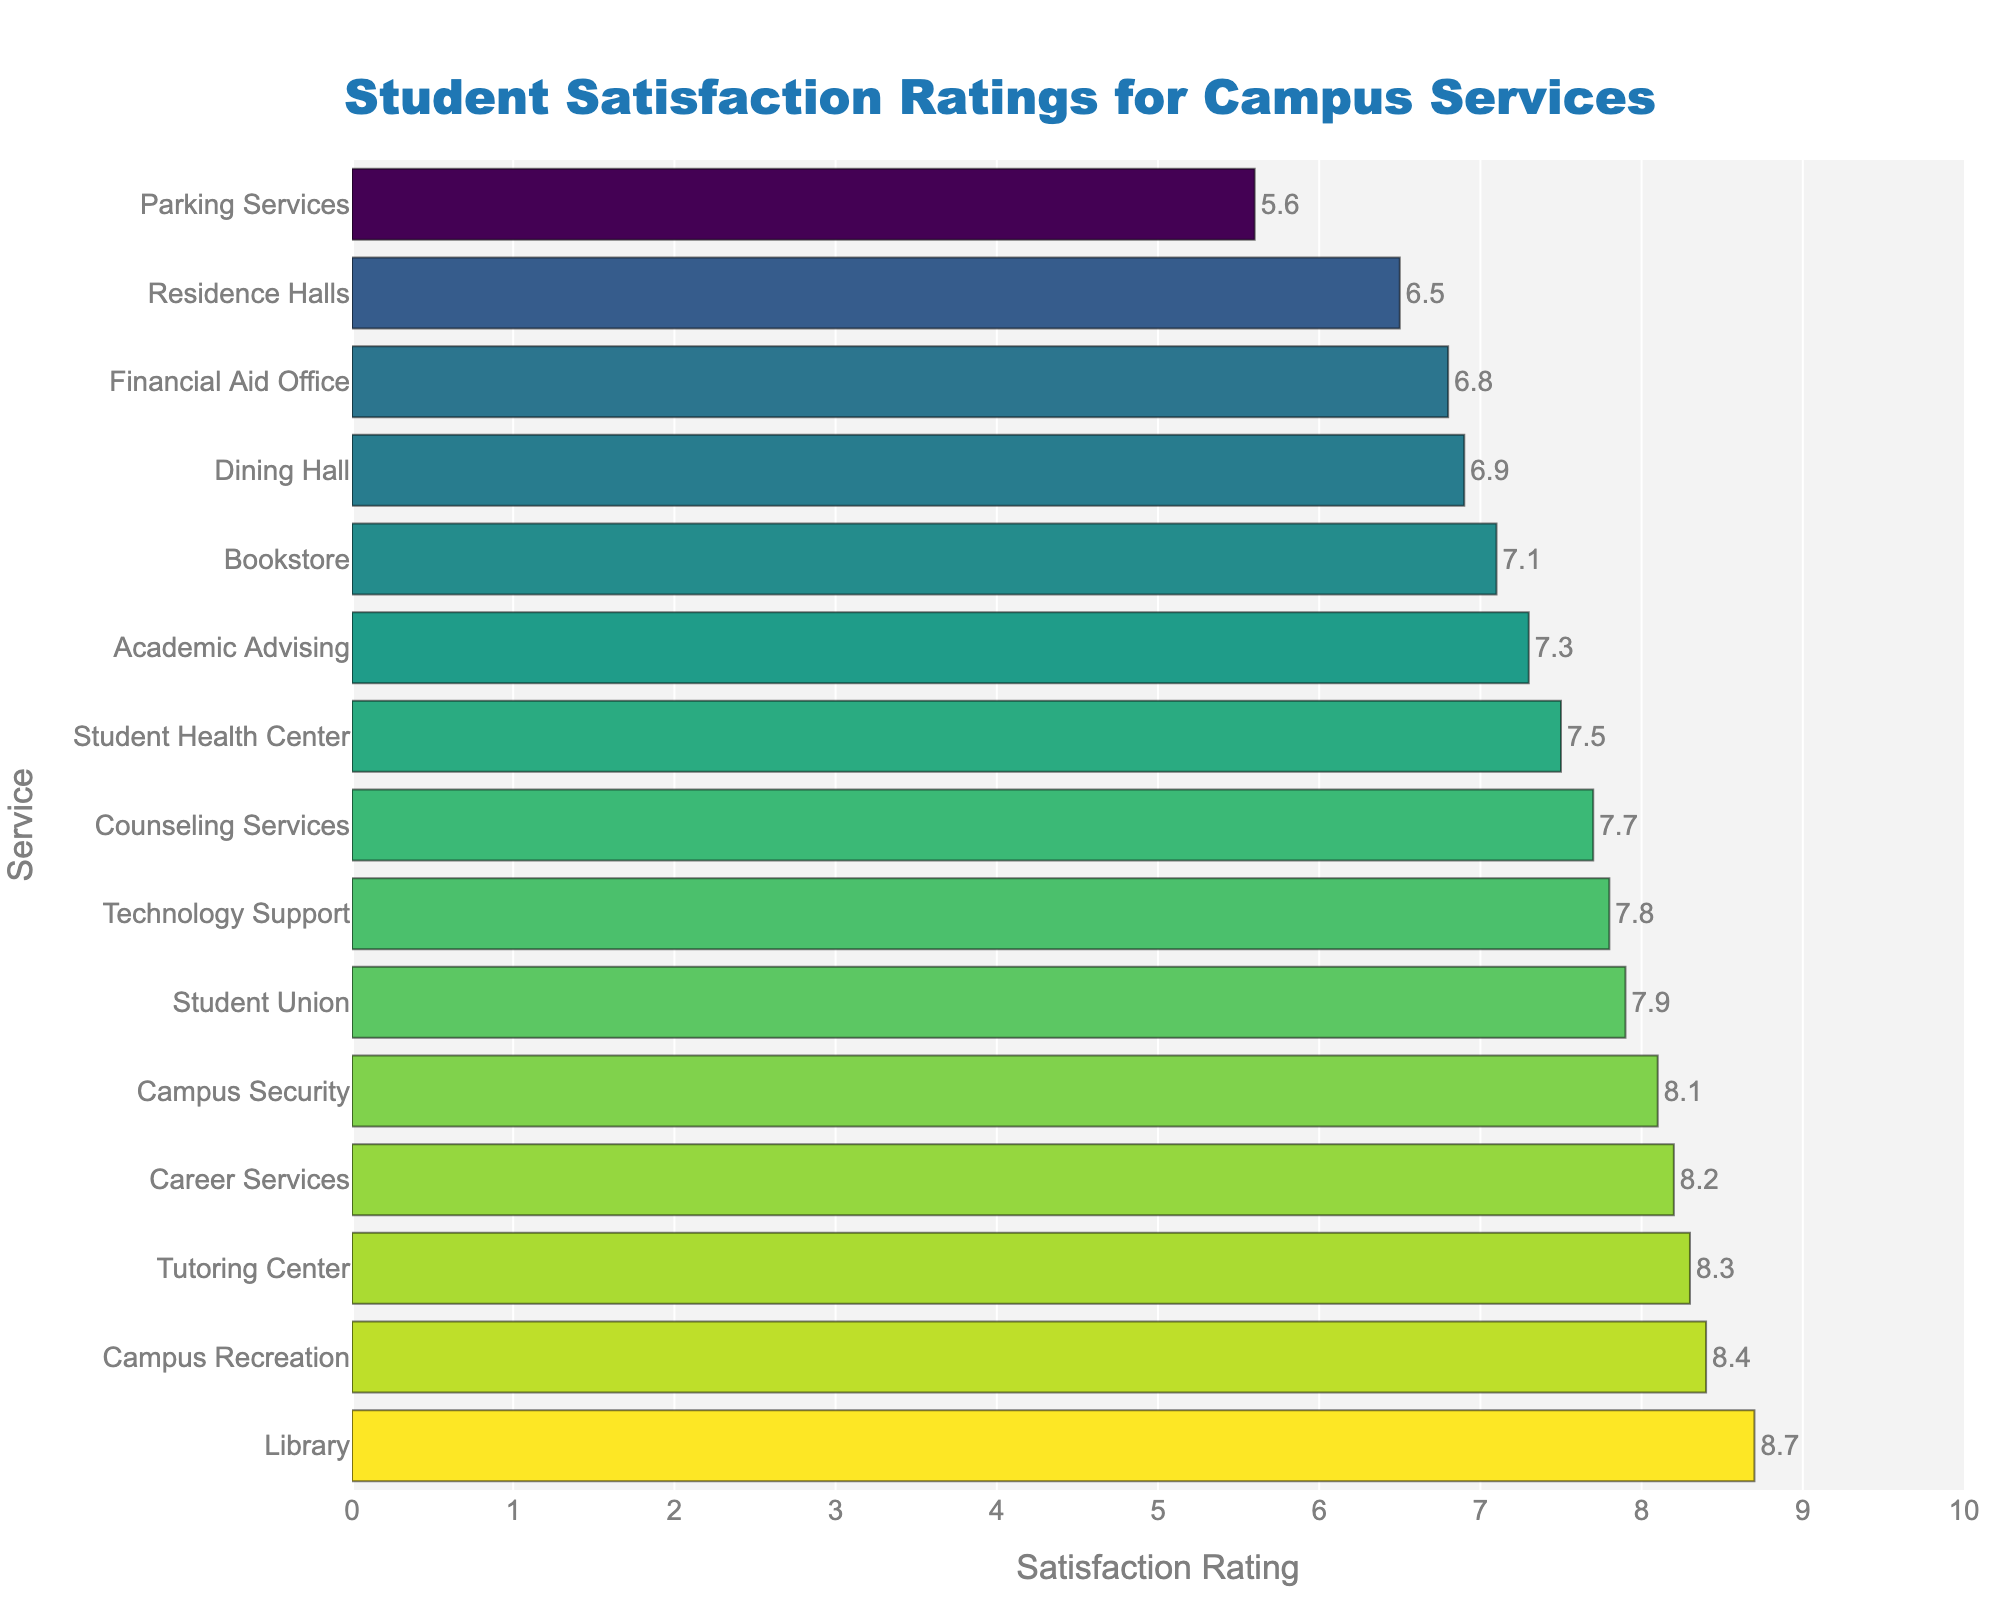What's the highest satisfaction rating for any campus service? The highest bar in the chart represents the highest satisfaction rating. By looking at the chart, the tallest bar belongs to the Library with a rating of 8.7.
Answer: 8.7 What is the difference in satisfaction ratings between the highest-rated and lowest-rated campus services? Identify the tallest and shortest bars in the chart. The highest rating is for the Library (8.7), and the lowest rating is for Parking Services (5.6). Subtract the lowest rating from the highest rating: 8.7 - 5.6 = 3.1.
Answer: 3.1 Which two services have the closest satisfaction ratings and what are those ratings? Look for bars that are nearly the same height. The closest bars in height belong to Student Union and Counseling Services with ratings of 7.9 and 7.7 respectively.
Answer: Student Union (7.9), Counseling Services (7.7) What is the average satisfaction rating of Career Services and Campus Recreation? Add the ratings of Career Services (8.2) and Campus Recreation (8.4), then divide by 2: (8.2 + 8.4) / 2 = 8.3.
Answer: 8.3 How many services have a satisfaction rating of 8.0 or higher? Count all the bars that reach or exceed the 8.0 mark. Services are Library, Career Services, Campus Recreation, Campus Security, Tutoring Center, and Student Union, which count to 6 services.
Answer: 6 Which service has a higher satisfaction rating: Financial Aid Office or Bookstore? Compare the bars representing Financial Aid Office (6.8) and Bookstore (7.1). The Bookstore has the higher rating.
Answer: Bookstore What is the combined satisfaction rating of Technology Support, Academic Advising, and Residence Halls? Add the ratings of Technology Support (7.8), Academic Advising (7.3), and Residence Halls (6.5): 7.8 + 7.3 + 6.5 = 21.6.
Answer: 21.6 Which service needs the most improvement based on the satisfaction rating? Identify the shortest bar in the chart, which represents the lowest satisfaction rating. Parking Services has the lowest rating of 5.6, indicating it needs the most improvement.
Answer: Parking Services How does the satisfaction rating of Dining Hall compare to the average rating of all services? First, calculate the average rating of all services. Sum all ratings: 8.7 + 6.9 + 7.5 + 8.2 + 8.4 + 7.8 + 7.3 + 6.5 + 8.1 + 5.6 + 6.8 + 7.1 + 8.3 + 7.9 + 7.7 = 112.8. There are 15 services, so the average is 112.8 / 15 = 7.52. Dining Hall has a rating of 6.9, which is below the average of 7.52.
Answer: Below Average 